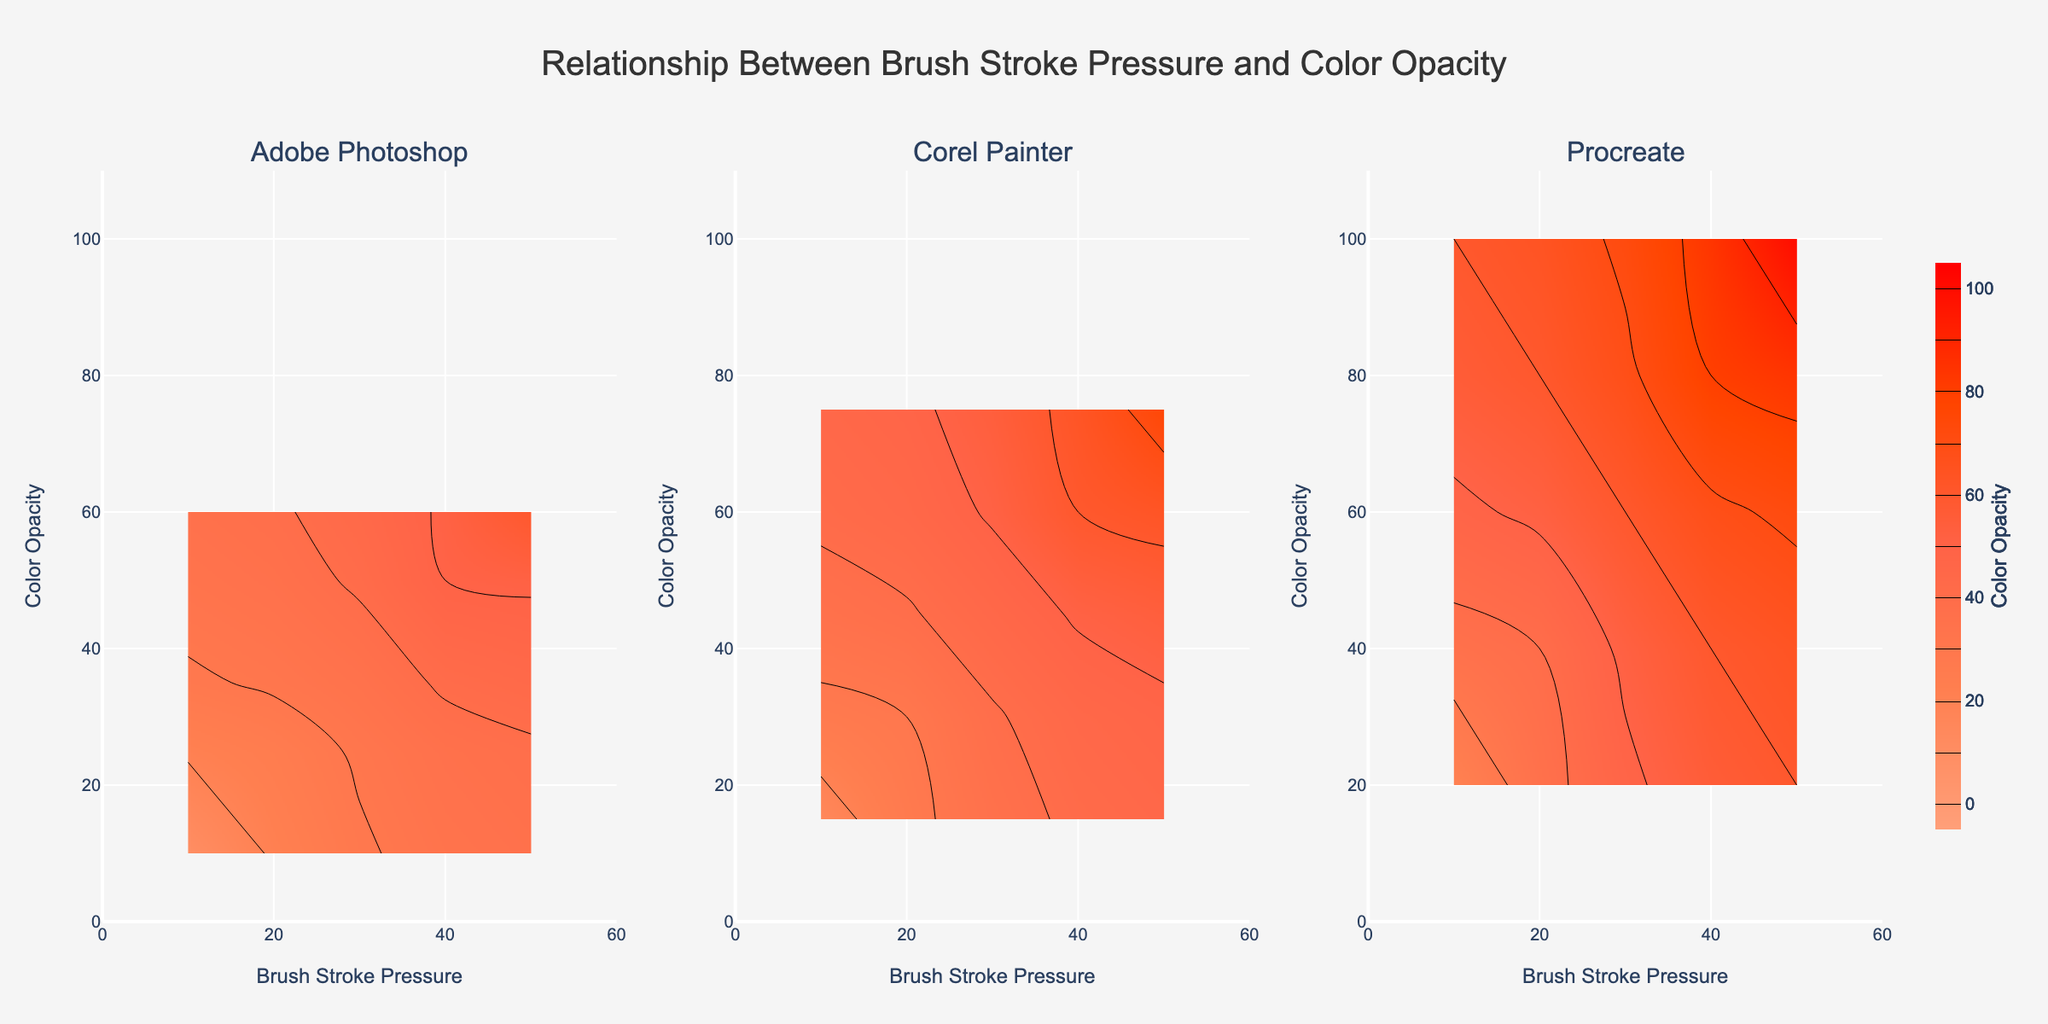What's the title of the plot? The title of the plot is displayed at the top and provides an overview of the information presented.
Answer: Relationship Between Brush Stroke Pressure and Color Opacity What are the three digital tools compared in the plot? The subplot titles indicate the names of the digital tools compared in the figure.
Answer: Adobe Photoshop, Corel Painter, Procreate What is the brush stroke pressure range shown on the x-axis? The x-axis range is indicated by the axis title and tick marks for all subplots, which go from 0 to 60.
Answer: 0 to 60 Which tool shows the highest color opacity at maximum brush stroke pressure? By examining the contour plots, the color opacity values can be seen, and Procreate shows the highest at maximum brush stroke pressure (50).
Answer: Procreate Which digital tool appears to increase color opacity more steeply with brush stroke pressure? By looking at the slope or the gradient of the contour lines, Procreate has a steeper increase in color opacity as brush stroke pressure increases compared to the other tools.
Answer: Procreate At a brush stroke pressure of 30, which tool has the highest color opacity? By locating the brush stroke pressure of 30 along the x-axis for each subplot and observing the corresponding color opacity, Procreate shows the highest value.
Answer: Procreate How does Corel Painter's color opacity at a brush stroke pressure of 20 compare to Adobe Photoshop's color opacity at the same pressure? By examining the pressure value of 20 in both Corel Painter and Adobe Photoshop subplots, Corel Painter has a higher color opacity value.
Answer: Corel Painter is higher What is the difference in maximum color opacity between Adobe Photoshop and Corel Painter? From the contour plots, the maximum color opacity for Adobe Photoshop is 60 and for Corel Painter is 75, thus the difference is 75 - 60.
Answer: 15 What is the color used to represent the highest color opacity values? By looking at the color gradient or color scale on the contour plots, the highest color opacity values are represented using a distinct deep red color.
Answer: Deep red 